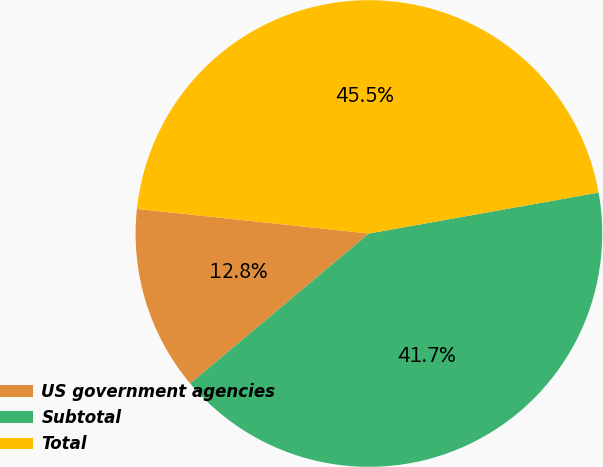Convert chart. <chart><loc_0><loc_0><loc_500><loc_500><pie_chart><fcel>US government agencies<fcel>Subtotal<fcel>Total<nl><fcel>12.8%<fcel>41.69%<fcel>45.51%<nl></chart> 